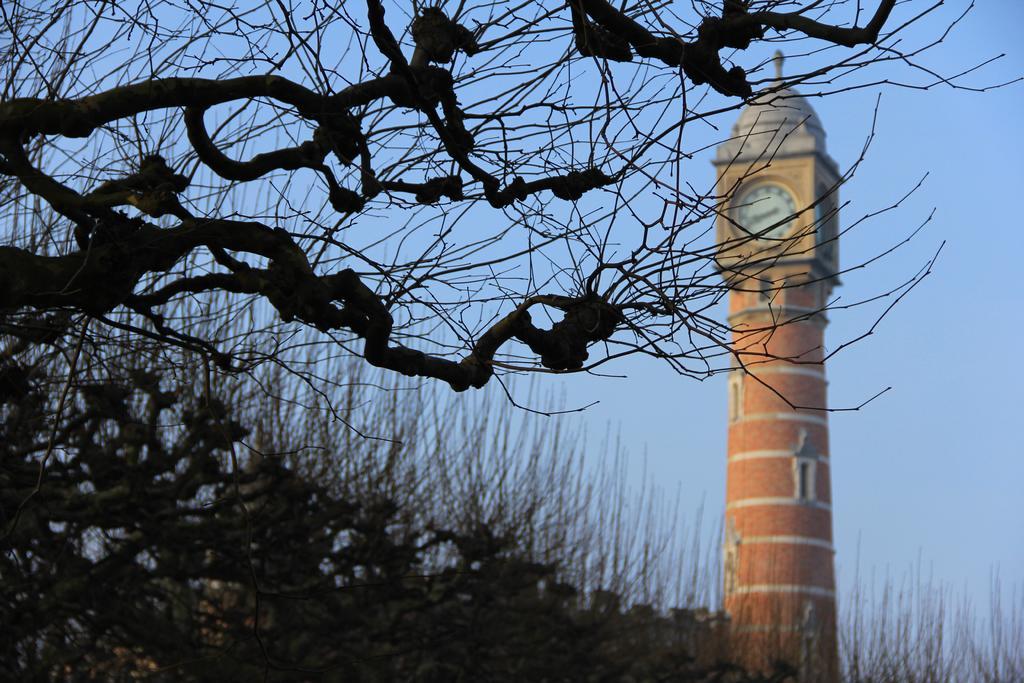In one or two sentences, can you explain what this image depicts? In this picture we can see trees and a tower with windows and a clock on it and in the background we can see the sky. 